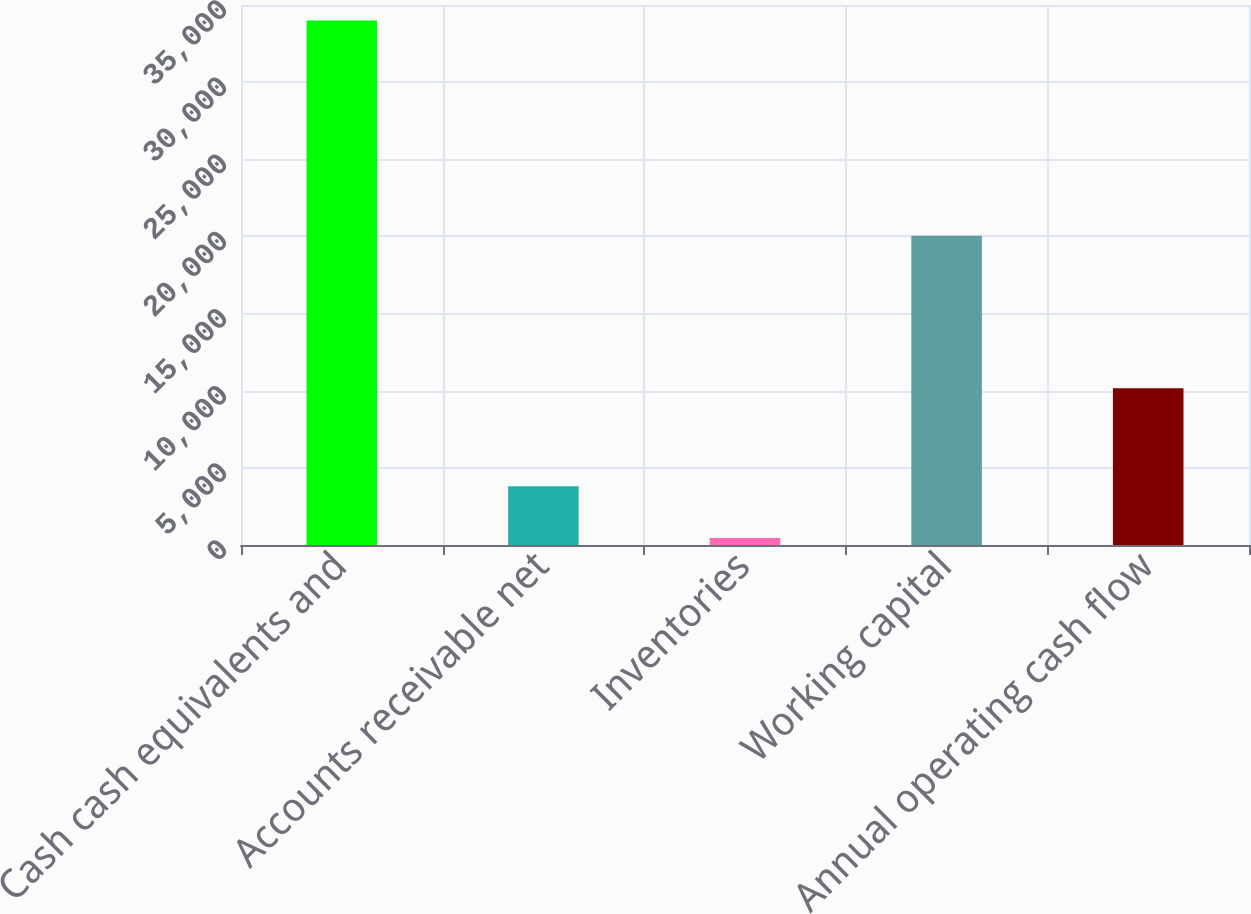Convert chart. <chart><loc_0><loc_0><loc_500><loc_500><bar_chart><fcel>Cash cash equivalents and<fcel>Accounts receivable net<fcel>Inventories<fcel>Working capital<fcel>Annual operating cash flow<nl><fcel>33992<fcel>3808.7<fcel>455<fcel>20049<fcel>10159<nl></chart> 